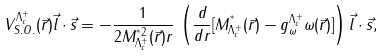Convert formula to latex. <formula><loc_0><loc_0><loc_500><loc_500>V ^ { \Lambda ^ { + } _ { c } } _ { S . O . } ( \vec { r } ) \vec { l } \cdot \vec { s } = - \frac { 1 } { 2 M ^ { ^ { * } 2 } _ { \Lambda ^ { + } _ { c } } ( \vec { r } ) r } \, \left ( \frac { d } { d r } [ M ^ { ^ { * } } _ { \Lambda ^ { + } _ { c } } ( \vec { r } ) - g ^ { \Lambda ^ { + } _ { c } } _ { \omega } \omega ( \vec { r } ) ] \right ) \vec { l } \cdot \vec { s } ,</formula> 